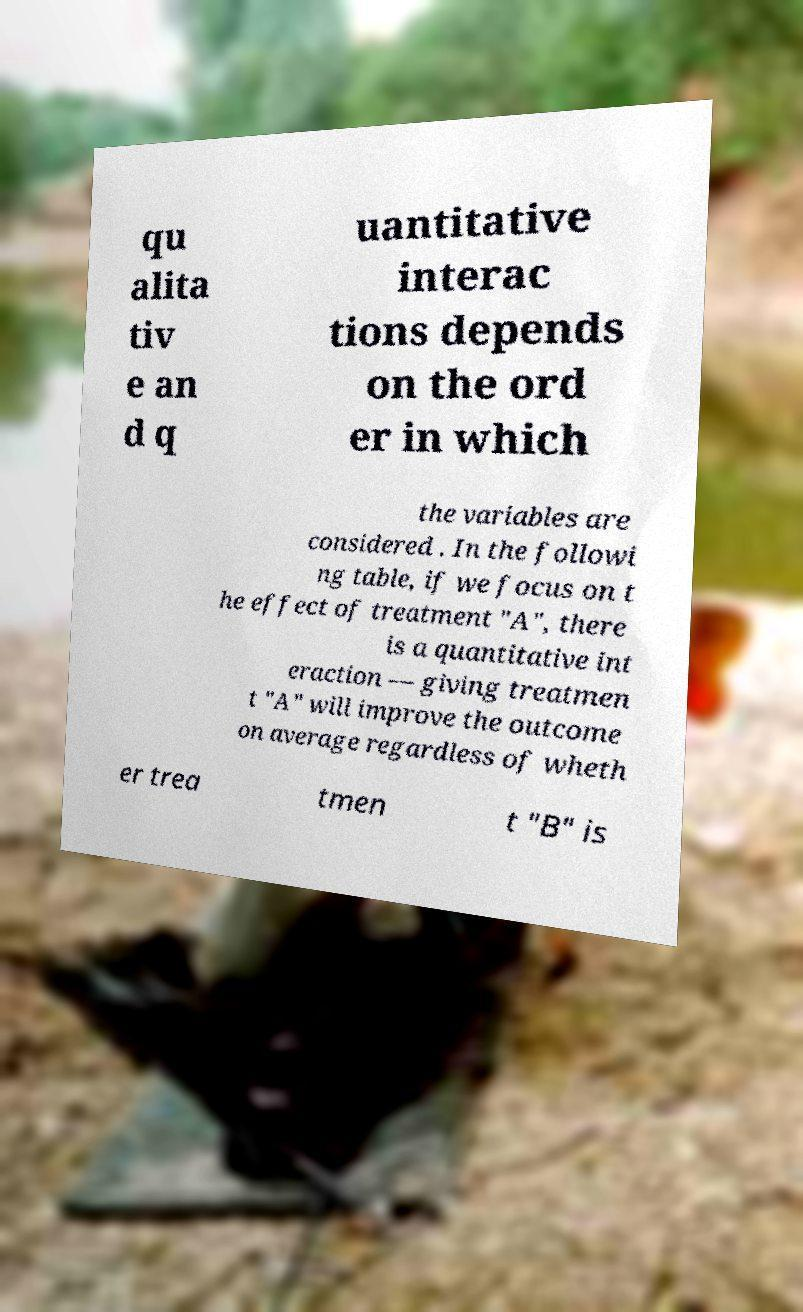Please identify and transcribe the text found in this image. qu alita tiv e an d q uantitative interac tions depends on the ord er in which the variables are considered . In the followi ng table, if we focus on t he effect of treatment "A", there is a quantitative int eraction — giving treatmen t "A" will improve the outcome on average regardless of wheth er trea tmen t "B" is 